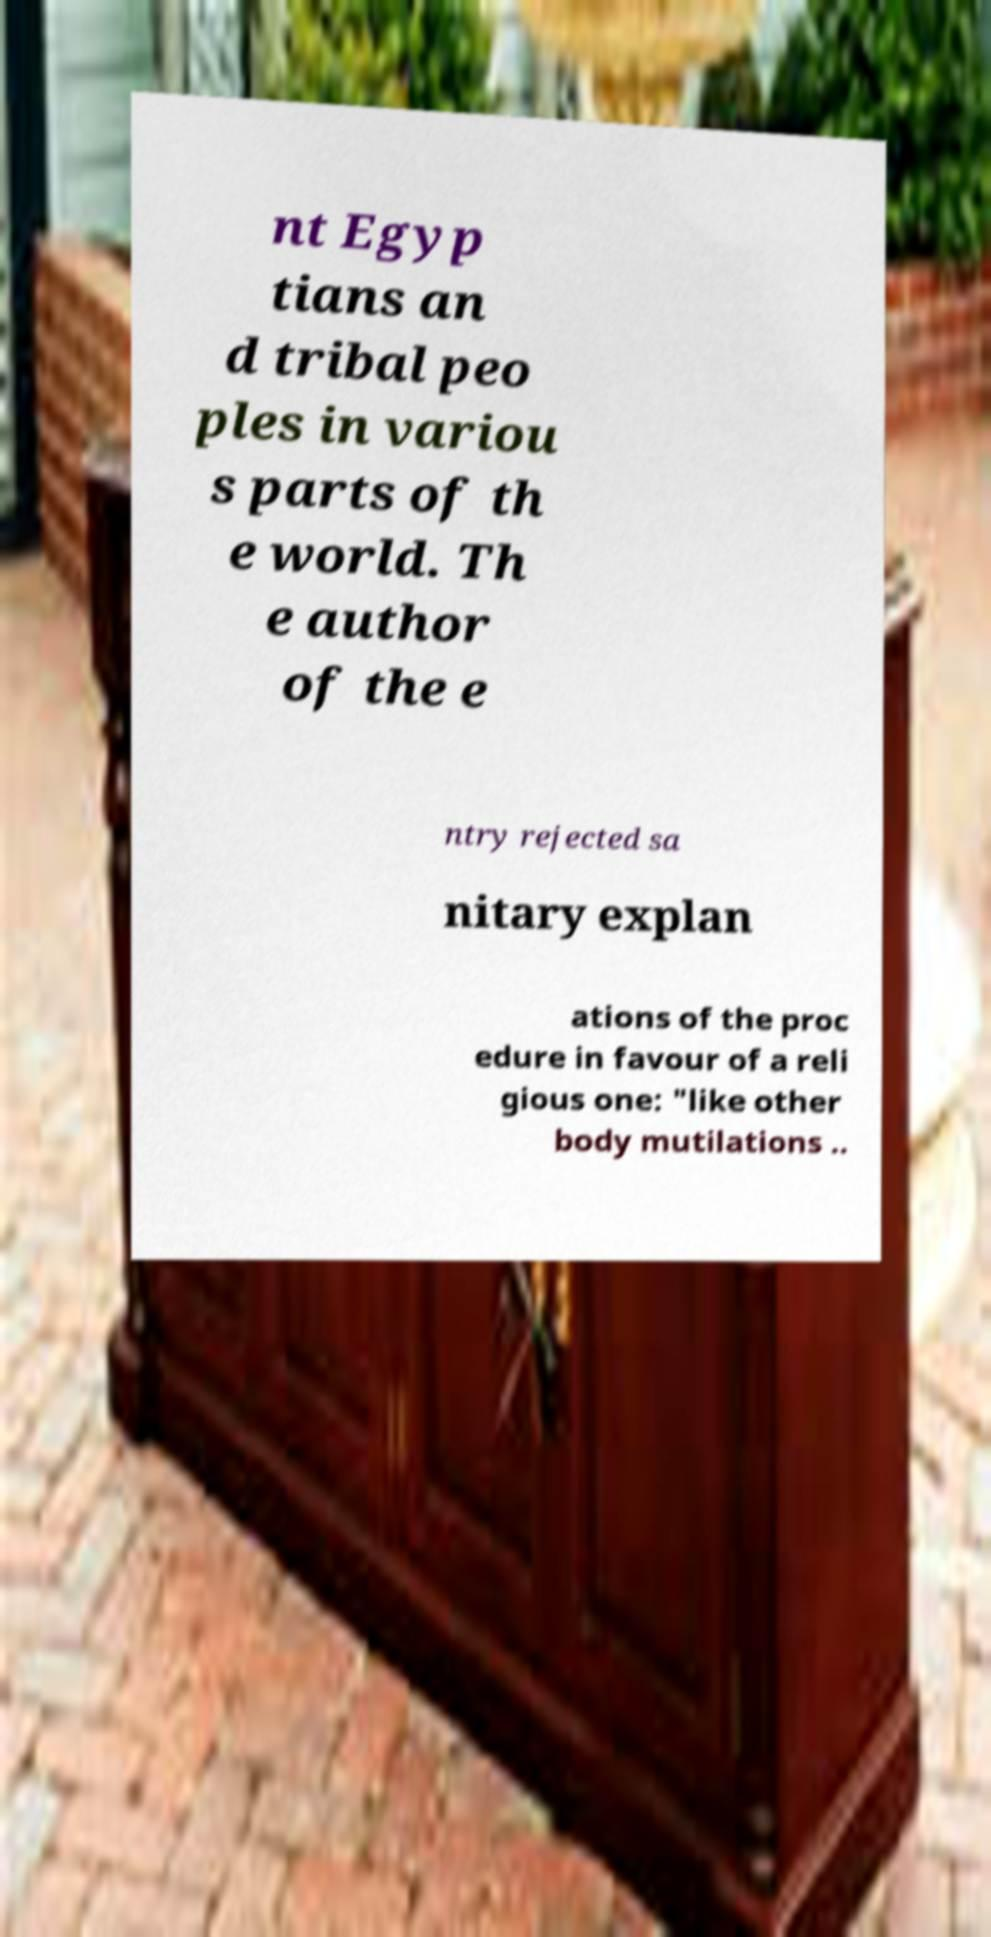What messages or text are displayed in this image? I need them in a readable, typed format. nt Egyp tians an d tribal peo ples in variou s parts of th e world. Th e author of the e ntry rejected sa nitary explan ations of the proc edure in favour of a reli gious one: "like other body mutilations .. 